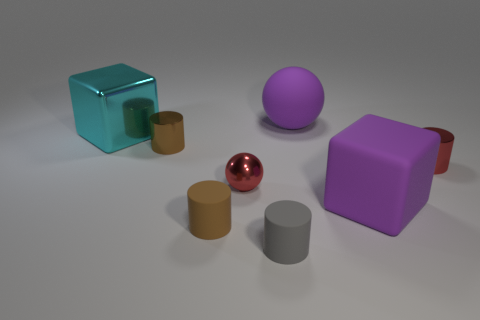How many other objects are there of the same material as the small sphere?
Your answer should be compact. 3. There is a metal cube; is it the same size as the red metal thing on the right side of the purple rubber block?
Provide a short and direct response. No. Is the number of large shiny things that are right of the big purple matte sphere less than the number of tiny gray rubber cylinders right of the small gray object?
Provide a succinct answer. No. There is a red shiny thing that is to the right of the tiny gray cylinder; how big is it?
Keep it short and to the point. Small. Does the gray cylinder have the same size as the brown rubber cylinder?
Your response must be concise. Yes. What number of small cylinders are both left of the tiny red metallic cylinder and behind the metal sphere?
Keep it short and to the point. 1. What number of gray objects are matte objects or small matte cylinders?
Your answer should be compact. 1. How many rubber things are either spheres or small gray objects?
Give a very brief answer. 2. Is there a brown metallic object?
Ensure brevity in your answer.  Yes. Do the brown metallic thing and the small gray object have the same shape?
Offer a very short reply. Yes. 